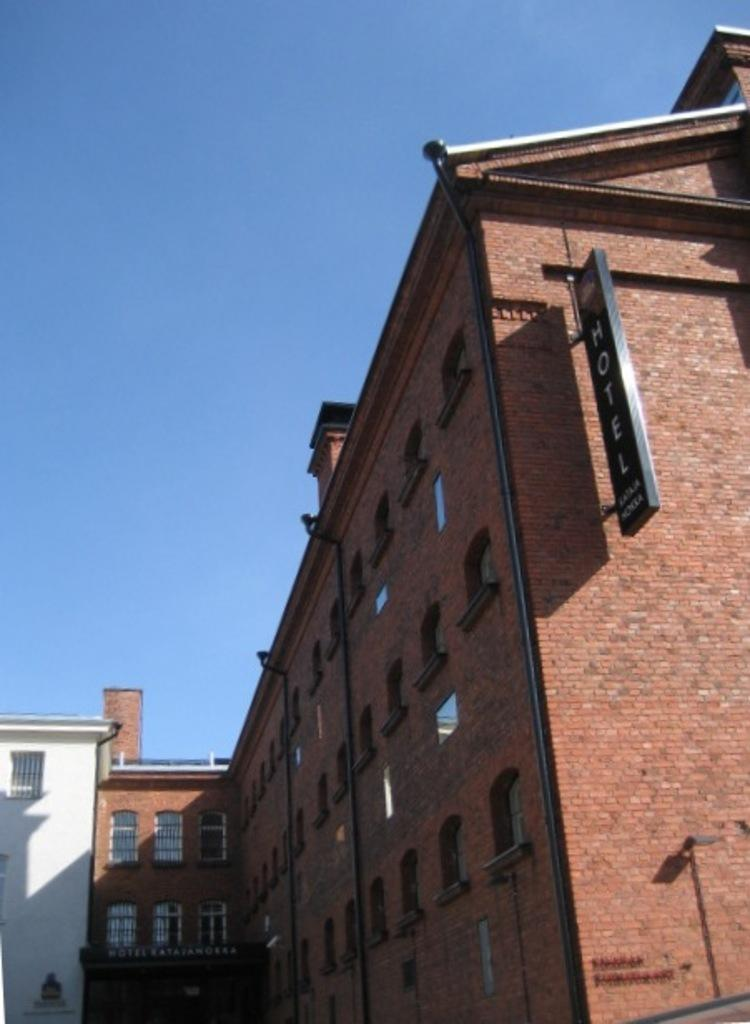What type of structures are present in the image? There are buildings in the image. What colors are the buildings? The buildings are in red and white colors. What is visible at the top of the image? The sky is visible at the top of the image. What is the condition of the sky in the image? The sky is clear in the image. What type of silk is draped over the buildings in the image? There is no silk present in the image; the buildings are in red and white colors. Can you tell me the title of the book that is lying on the roof of the building? There is no book present in the image; the image only features buildings and a clear sky. 